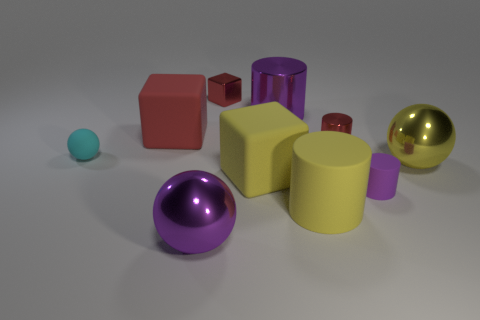Subtract all cylinders. How many objects are left? 6 Subtract 1 yellow blocks. How many objects are left? 9 Subtract all large red matte balls. Subtract all large yellow metallic things. How many objects are left? 9 Add 7 purple things. How many purple things are left? 10 Add 7 yellow matte things. How many yellow matte things exist? 9 